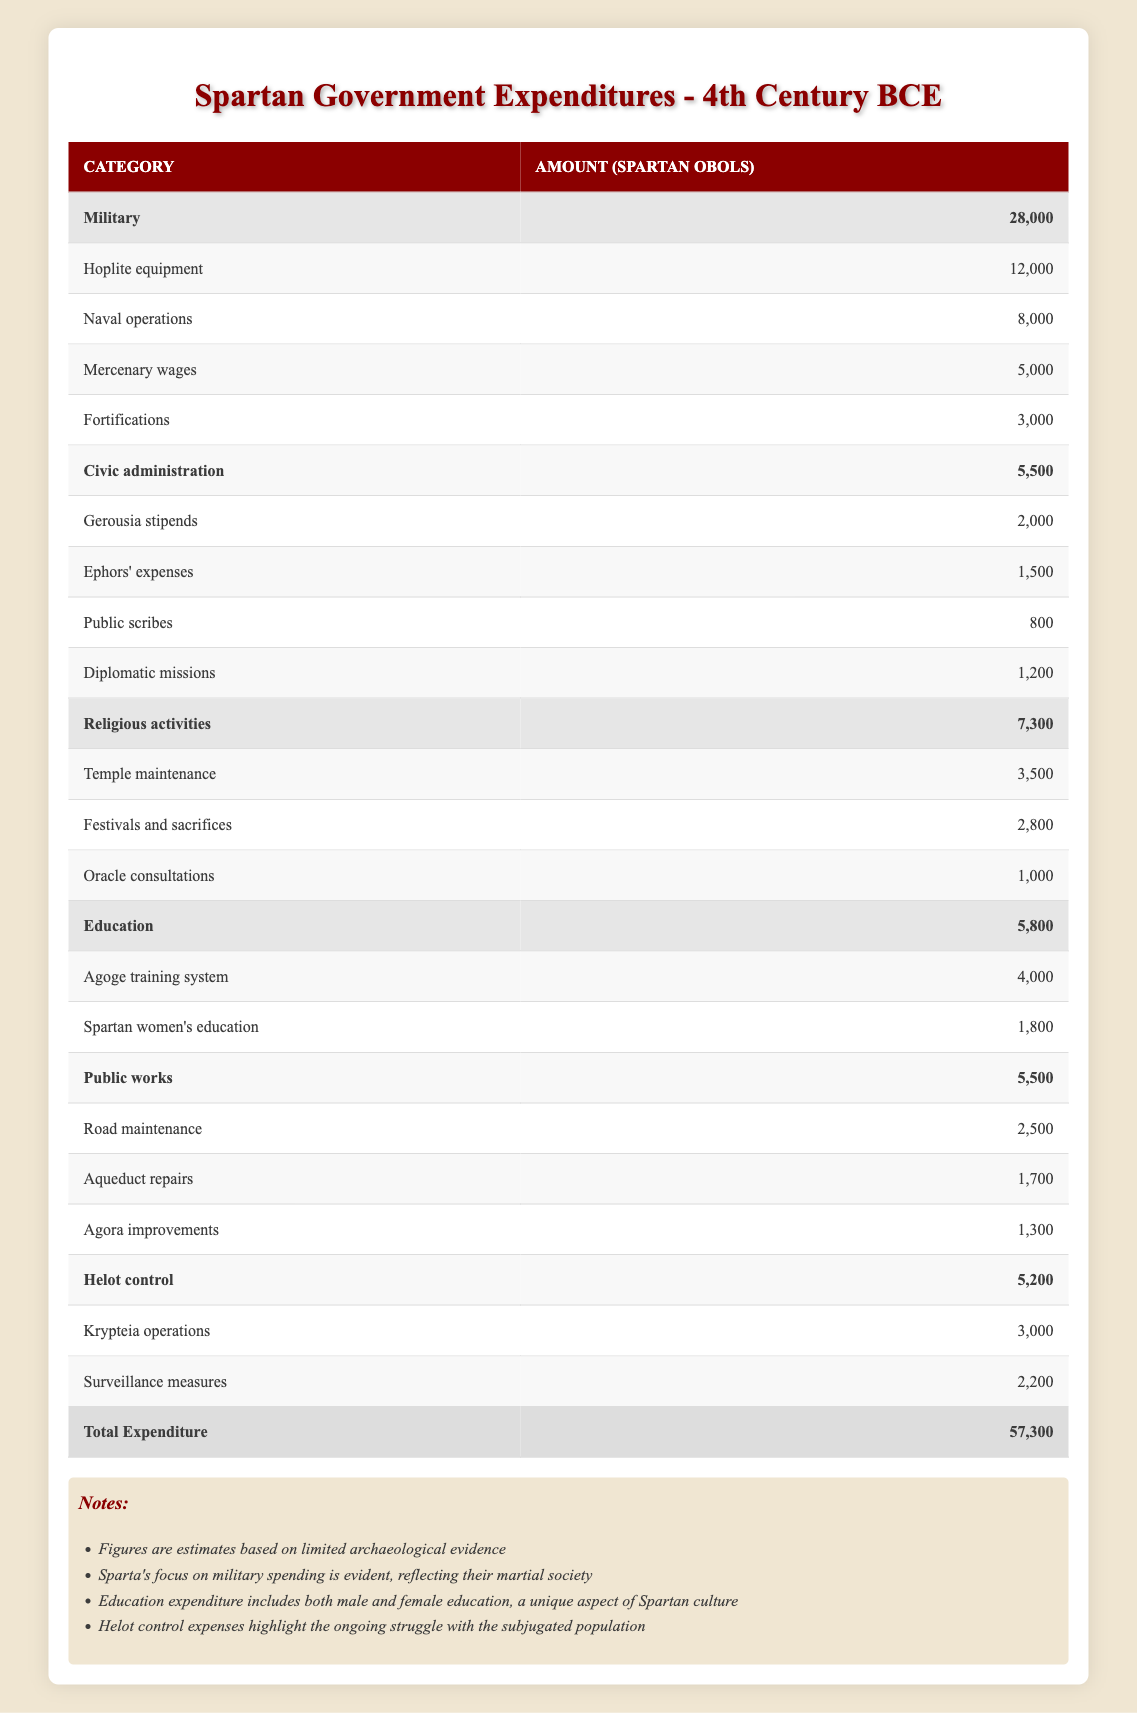What is the total expenditure of the Spartan government? The total expenditure is stated in the table at the bottom, which clearly shows the total as 57,300 Spartan obols.
Answer: 57,300 How much did Sparta spend on military in total? The table shows a separate total for military expenditures, which adds up the amounts listed under military: 12,000 (Hoplite equipment) + 8,000 (Naval operations) + 5,000 (Mercenary wages) + 3,000 (Fortifications) = 28,000 Spartan obols.
Answer: 28,000 Is the expenditure on education greater than that on civic administration? Education expenditure is listed as 5,800 and civic administration is listed as 5,500. Since 5,800 is greater than 5,500, the statement is true.
Answer: Yes What percentage of the total expenditure is allocated to religious activities? The expenditure for religious activities is 7,300 obols. To find the percentage: (7,300 / 57,300) * 100 = approximately 12.77%.
Answer: Approximately 12.77% How much more did Sparta spend on Hoplite equipment than on surveillance measures? Hoplite equipment spending is 12,000 obols and surveillance measures spending is 2,200 obols. The difference is 12,000 - 2,200 = 9,800 obols.
Answer: 9,800 What is the total amount spent on public works? The expenditures categorized under public works sum to: 2,500 (Road maintenance) + 1,700 (Aqueduct repairs) + 1,300 (Agora improvements) = 5,500 obols.
Answer: 5,500 Did the expenditures for Helot control exceed those for education? Helot control expenditures total 5,200 obols while education expenditures total 5,800 obols. Since 5,200 is less than 5,800, the statement is false.
Answer: No What is the average expenditure for the military subcategories presented? The military has four subcategories. The total is 28,000 obols (from previous calculations). To find the average: 28,000 / 4 = 7,000 obols.
Answer: 7,000 